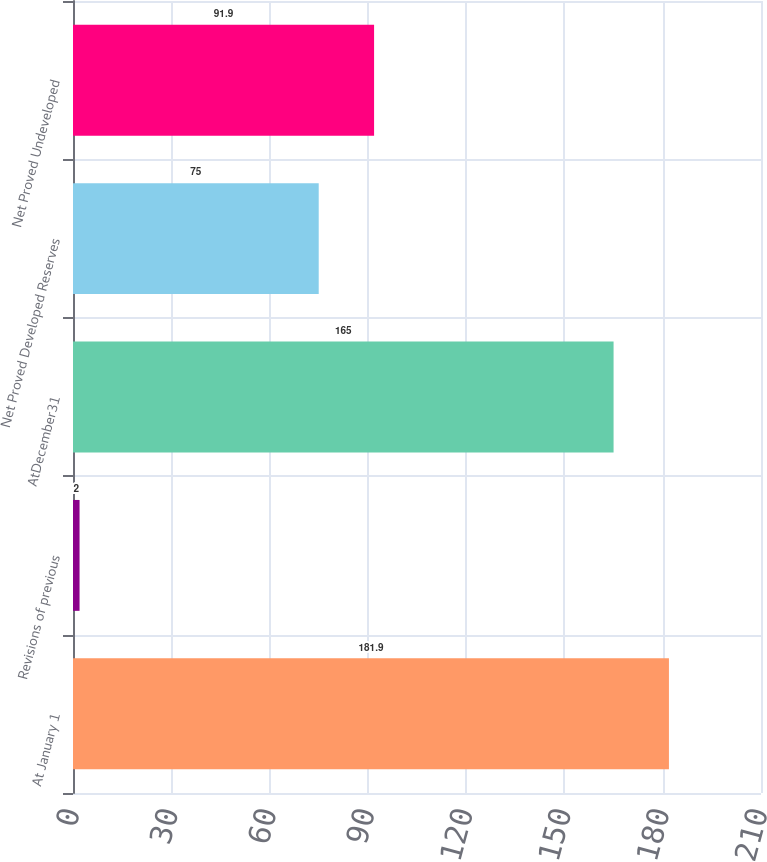Convert chart to OTSL. <chart><loc_0><loc_0><loc_500><loc_500><bar_chart><fcel>At January 1<fcel>Revisions of previous<fcel>AtDecember31<fcel>Net Proved Developed Reserves<fcel>Net Proved Undeveloped<nl><fcel>181.9<fcel>2<fcel>165<fcel>75<fcel>91.9<nl></chart> 